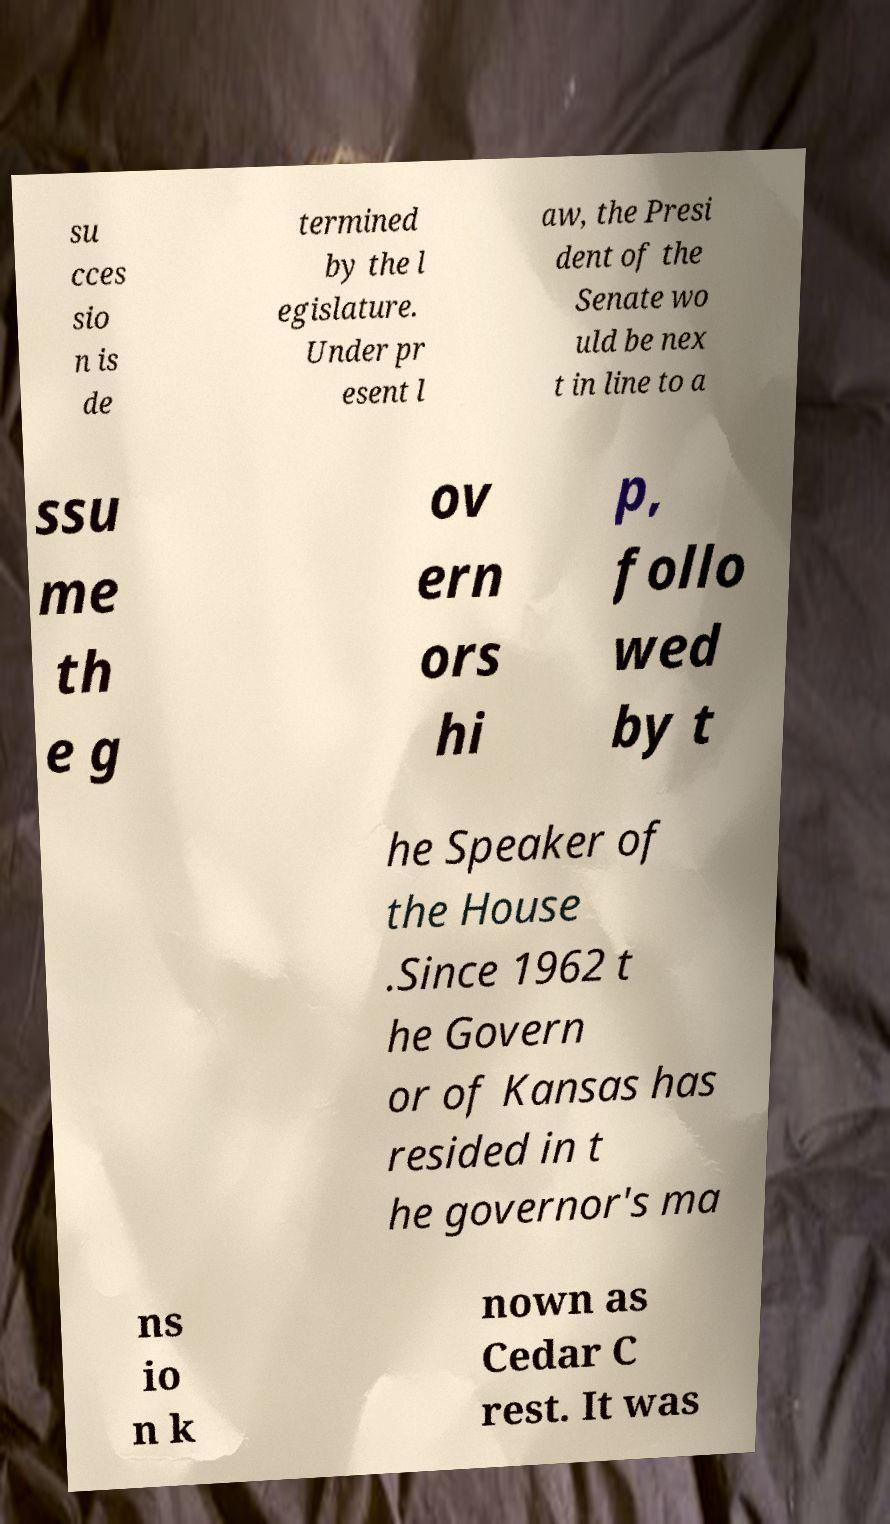There's text embedded in this image that I need extracted. Can you transcribe it verbatim? su cces sio n is de termined by the l egislature. Under pr esent l aw, the Presi dent of the Senate wo uld be nex t in line to a ssu me th e g ov ern ors hi p, follo wed by t he Speaker of the House .Since 1962 t he Govern or of Kansas has resided in t he governor's ma ns io n k nown as Cedar C rest. It was 